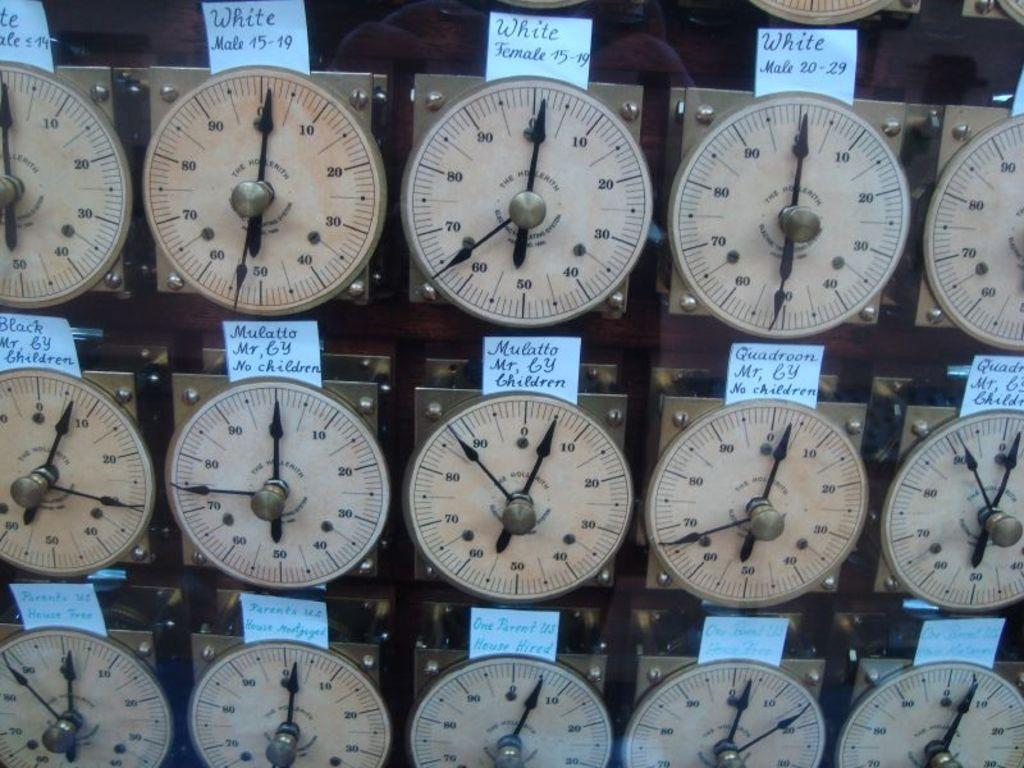Provide a one-sentence caption for the provided image. The top row of meters shown say the word White above them. 